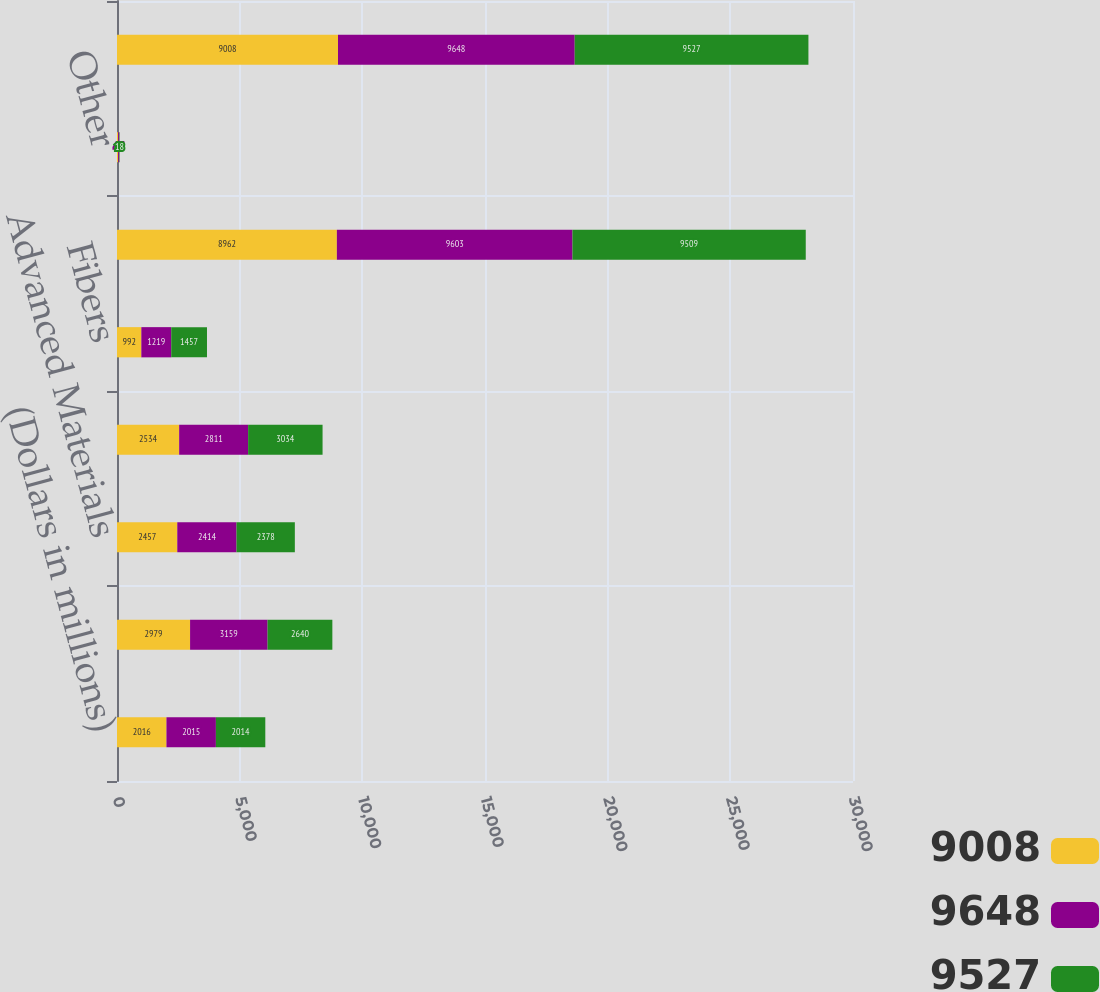Convert chart to OTSL. <chart><loc_0><loc_0><loc_500><loc_500><stacked_bar_chart><ecel><fcel>(Dollars in millions)<fcel>Additives & Functional<fcel>Advanced Materials<fcel>Chemical Intermediates<fcel>Fibers<fcel>Total Sales by Operating<fcel>Other<fcel>Total Sales<nl><fcel>9008<fcel>2016<fcel>2979<fcel>2457<fcel>2534<fcel>992<fcel>8962<fcel>46<fcel>9008<nl><fcel>9648<fcel>2015<fcel>3159<fcel>2414<fcel>2811<fcel>1219<fcel>9603<fcel>45<fcel>9648<nl><fcel>9527<fcel>2014<fcel>2640<fcel>2378<fcel>3034<fcel>1457<fcel>9509<fcel>18<fcel>9527<nl></chart> 